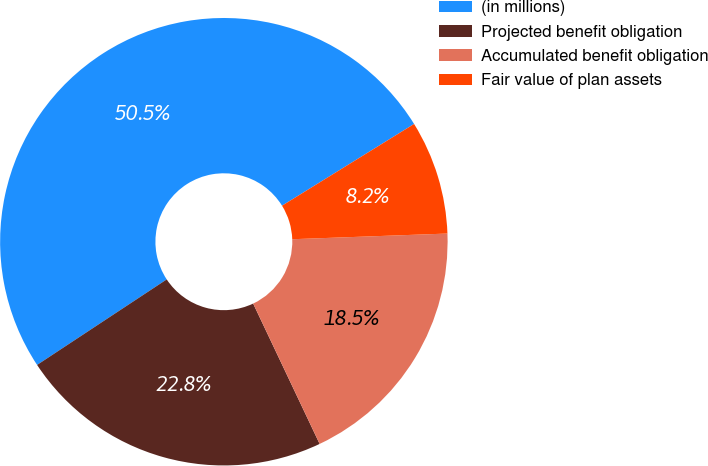Convert chart to OTSL. <chart><loc_0><loc_0><loc_500><loc_500><pie_chart><fcel>(in millions)<fcel>Projected benefit obligation<fcel>Accumulated benefit obligation<fcel>Fair value of plan assets<nl><fcel>50.46%<fcel>22.76%<fcel>18.54%<fcel>8.24%<nl></chart> 